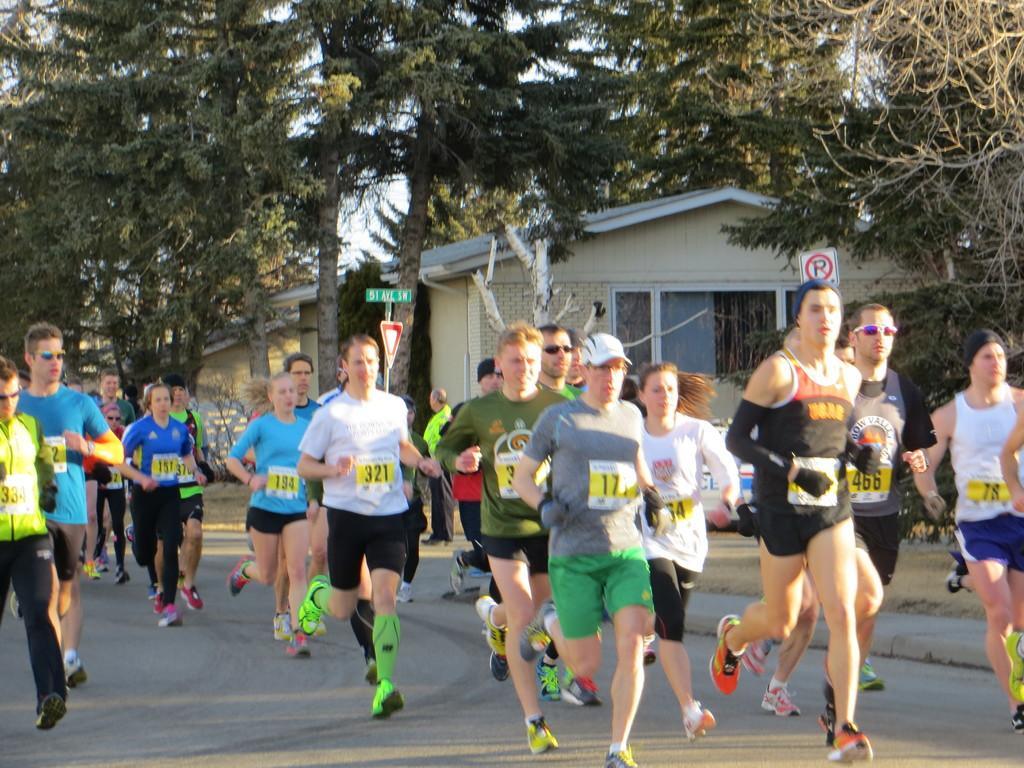Please provide a concise description of this image. This picture shows few people running on the road and we see trees and couple of sign boards on the sidewalk and we see houses. 